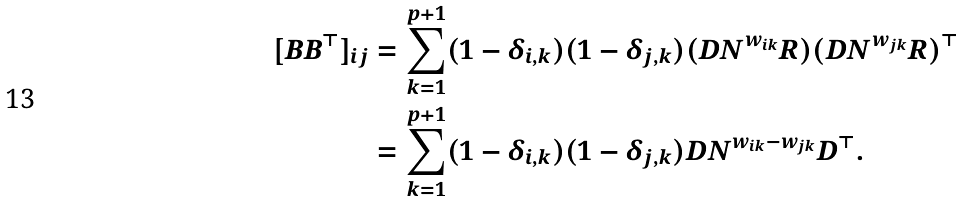Convert formula to latex. <formula><loc_0><loc_0><loc_500><loc_500>[ B B ^ { \top } ] _ { i j } & = \sum _ { k = 1 } ^ { p + 1 } ( 1 - \delta _ { i , k } ) ( 1 - \delta _ { j , k } ) ( D N ^ { w _ { i k } } R ) ( D N ^ { w _ { j k } } R ) ^ { \top } \\ & = \sum _ { k = 1 } ^ { p + 1 } ( 1 - \delta _ { i , k } ) ( 1 - \delta _ { j , k } ) D N ^ { w _ { i k } - w _ { j k } } D ^ { \top } .</formula> 